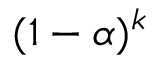<formula> <loc_0><loc_0><loc_500><loc_500>( 1 - \alpha ) ^ { k }</formula> 